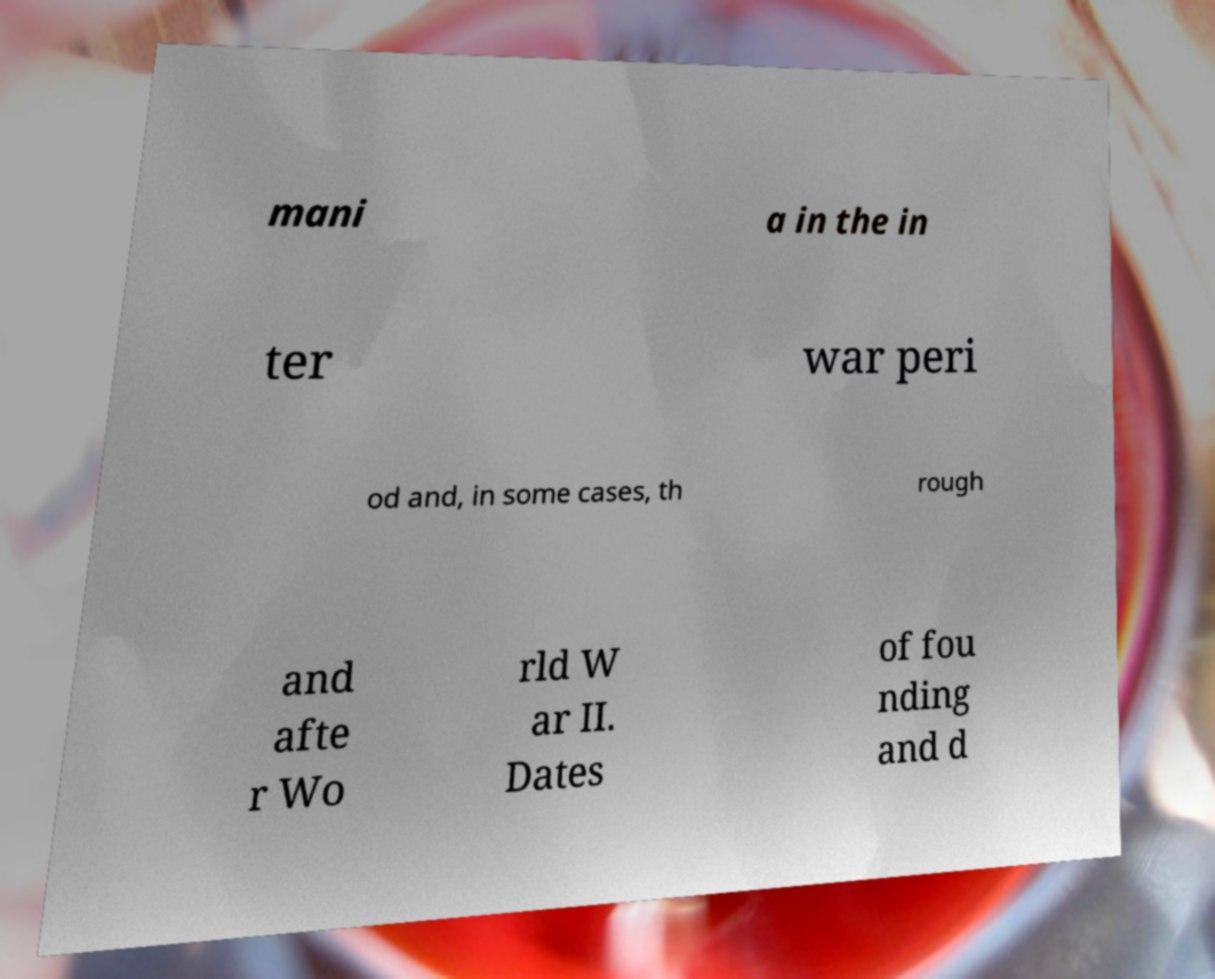I need the written content from this picture converted into text. Can you do that? mani a in the in ter war peri od and, in some cases, th rough and afte r Wo rld W ar II. Dates of fou nding and d 